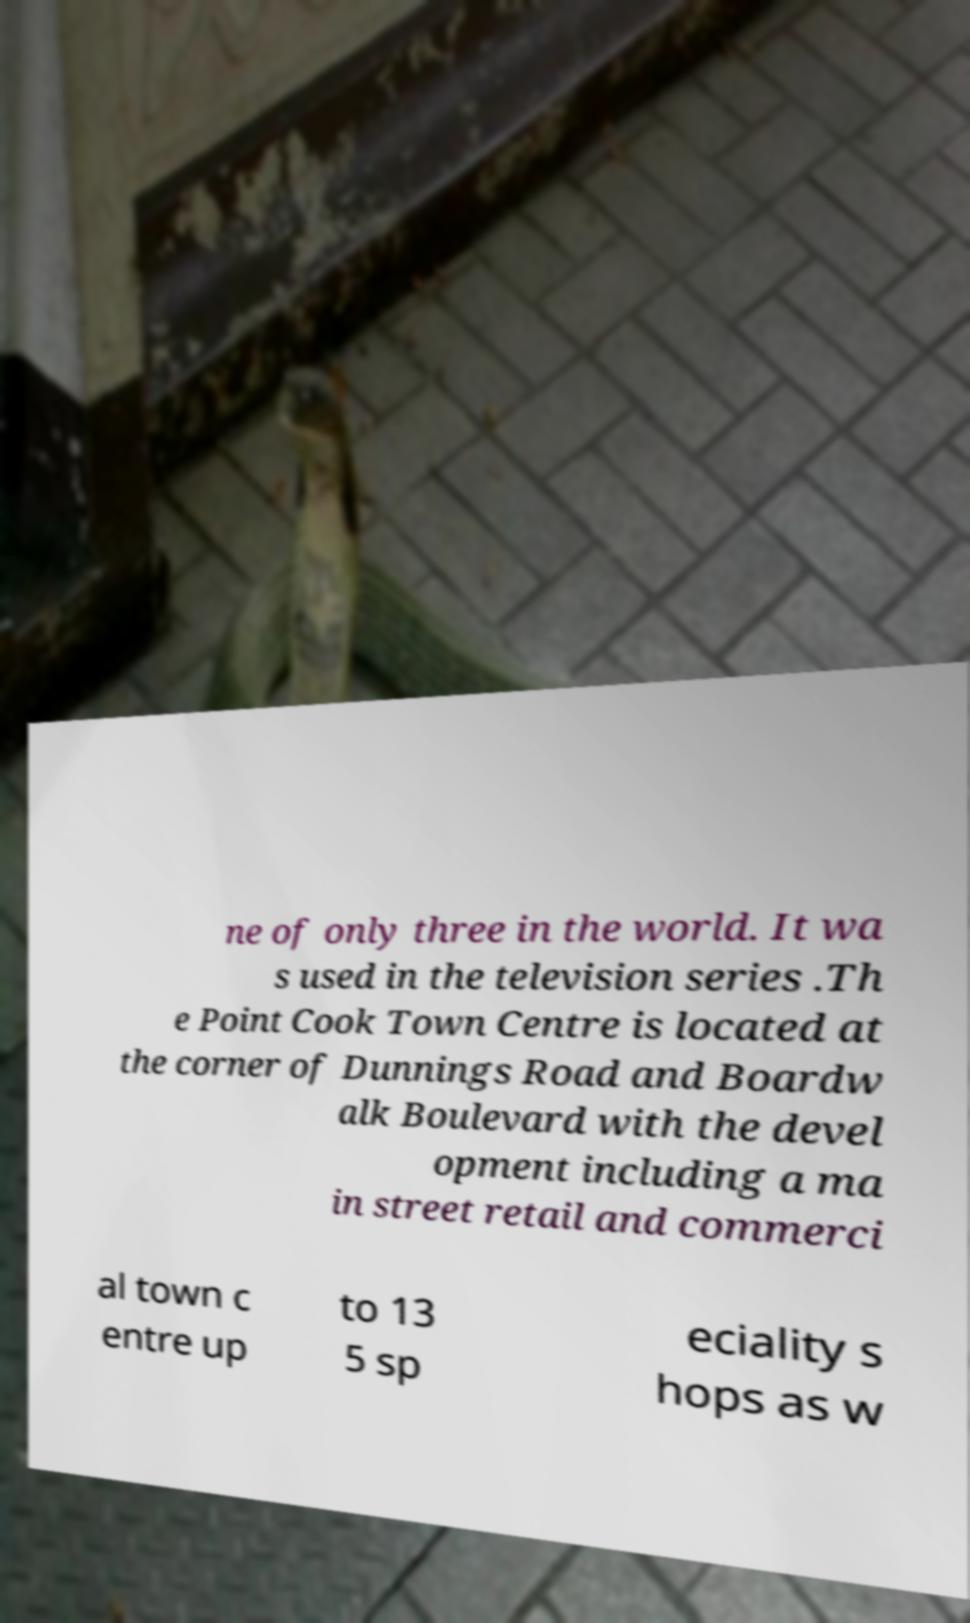Could you extract and type out the text from this image? ne of only three in the world. It wa s used in the television series .Th e Point Cook Town Centre is located at the corner of Dunnings Road and Boardw alk Boulevard with the devel opment including a ma in street retail and commerci al town c entre up to 13 5 sp eciality s hops as w 